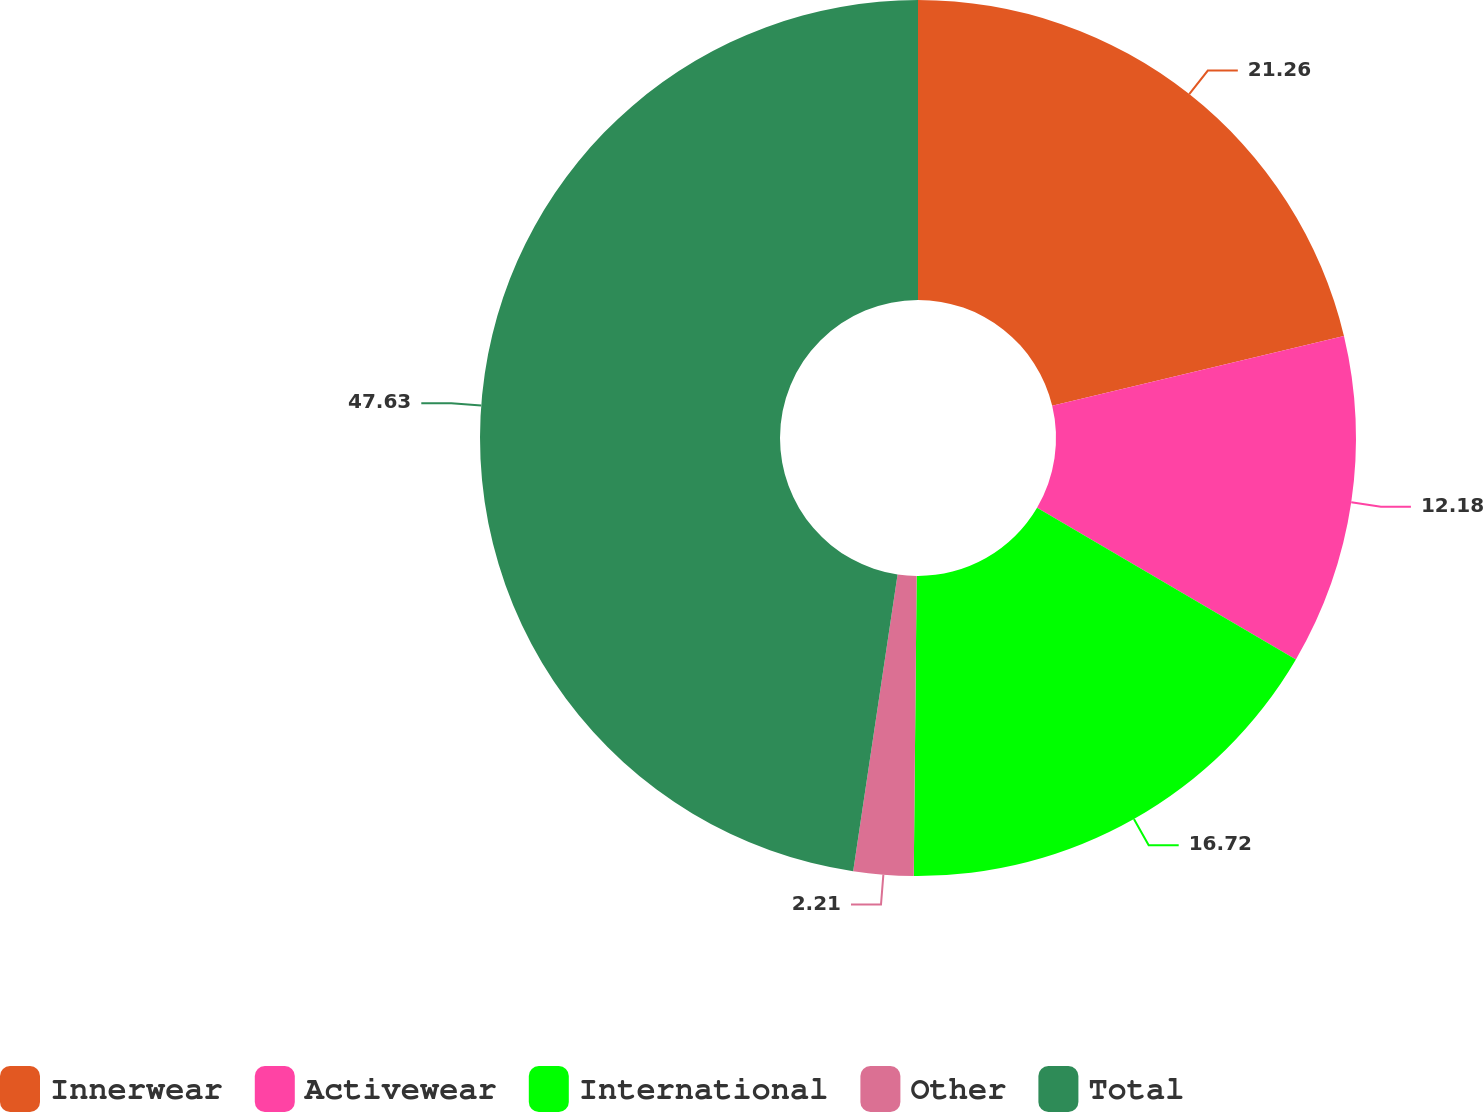Convert chart to OTSL. <chart><loc_0><loc_0><loc_500><loc_500><pie_chart><fcel>Innerwear<fcel>Activewear<fcel>International<fcel>Other<fcel>Total<nl><fcel>21.26%<fcel>12.18%<fcel>16.72%<fcel>2.21%<fcel>47.64%<nl></chart> 